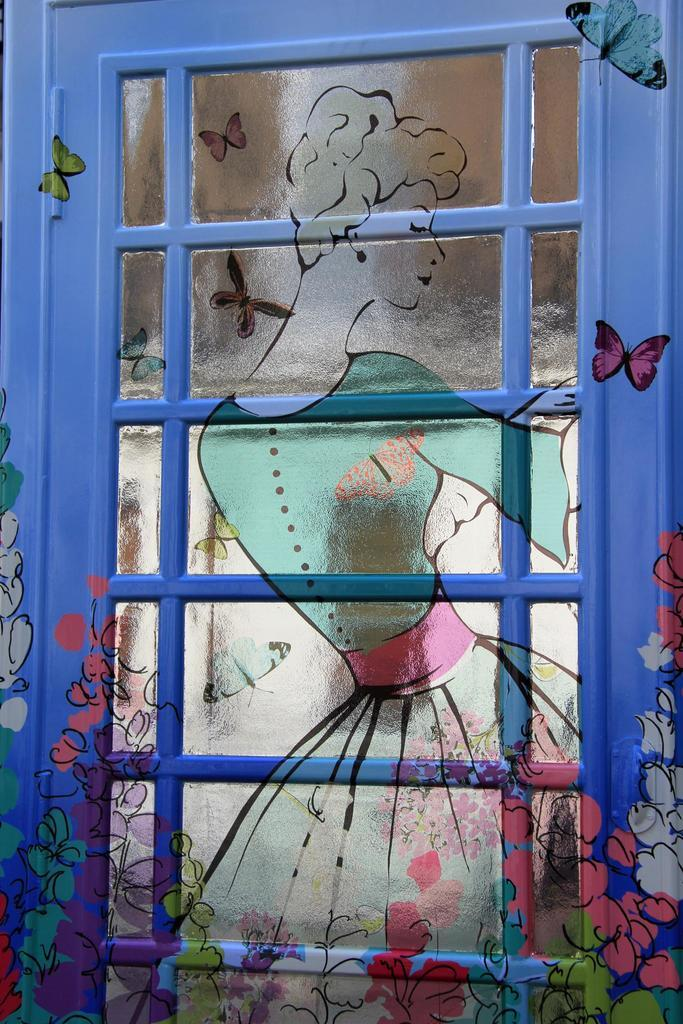What is on the window in the image? There is a painting on the window in the image. What type of pen is used to create the painting on the window? There is no mention of a pen being used to create the painting on the window, as the fact only states that there is a painting on the window. 